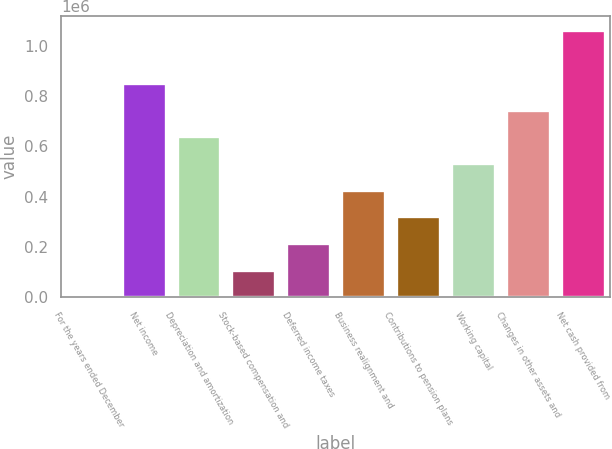<chart> <loc_0><loc_0><loc_500><loc_500><bar_chart><fcel>For the years ended December<fcel>Net income<fcel>Depreciation and amortization<fcel>Stock-based compensation and<fcel>Deferred income taxes<fcel>Business realignment and<fcel>Contributions to pension plans<fcel>Working capital<fcel>Changes in other assets and<fcel>Net cash provided from<nl><fcel>2009<fcel>853001<fcel>640253<fcel>108383<fcel>214757<fcel>427505<fcel>321131<fcel>533879<fcel>746627<fcel>1.06575e+06<nl></chart> 